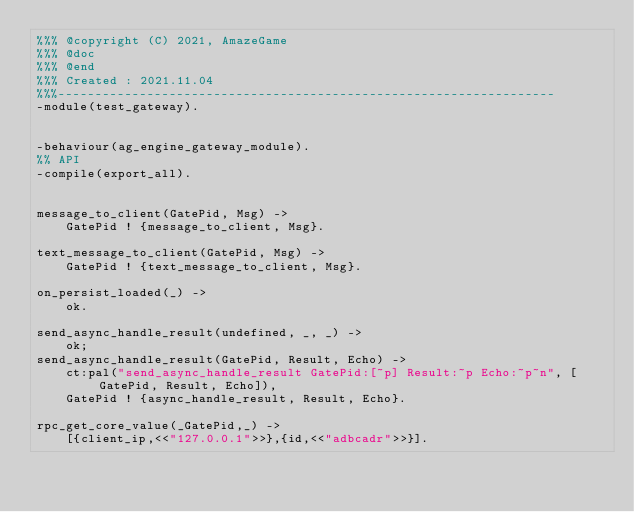Convert code to text. <code><loc_0><loc_0><loc_500><loc_500><_Erlang_>%%% @copyright (C) 2021, AmazeGame
%%% @doc
%%% @end
%%% Created : 2021.11.04
%%%-------------------------------------------------------------------
-module(test_gateway).


-behaviour(ag_engine_gateway_module).
%% API
-compile(export_all).


message_to_client(GatePid, Msg) ->
    GatePid ! {message_to_client, Msg}.

text_message_to_client(GatePid, Msg) ->
    GatePid ! {text_message_to_client, Msg}.

on_persist_loaded(_) ->
    ok.

send_async_handle_result(undefined, _, _) ->
    ok;
send_async_handle_result(GatePid, Result, Echo) ->
    ct:pal("send_async_handle_result GatePid:[~p] Result:~p Echo:~p~n", [GatePid, Result, Echo]),
    GatePid ! {async_handle_result, Result, Echo}.

rpc_get_core_value(_GatePid,_) ->
    [{client_ip,<<"127.0.0.1">>},{id,<<"adbcadr">>}].</code> 